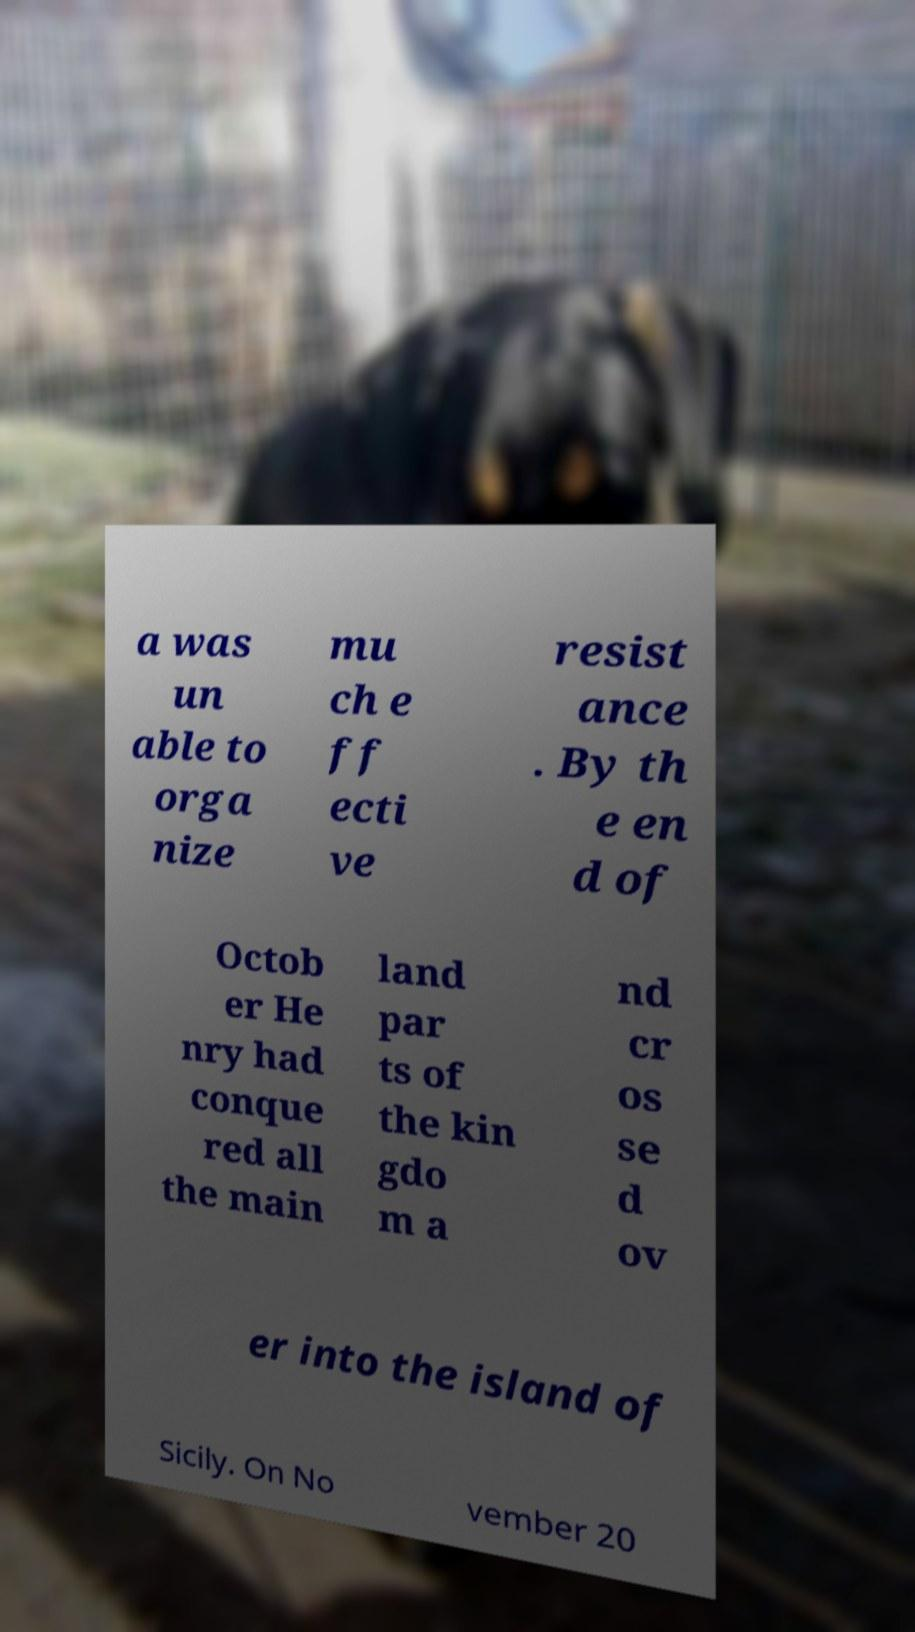Please read and relay the text visible in this image. What does it say? a was un able to orga nize mu ch e ff ecti ve resist ance . By th e en d of Octob er He nry had conque red all the main land par ts of the kin gdo m a nd cr os se d ov er into the island of Sicily. On No vember 20 